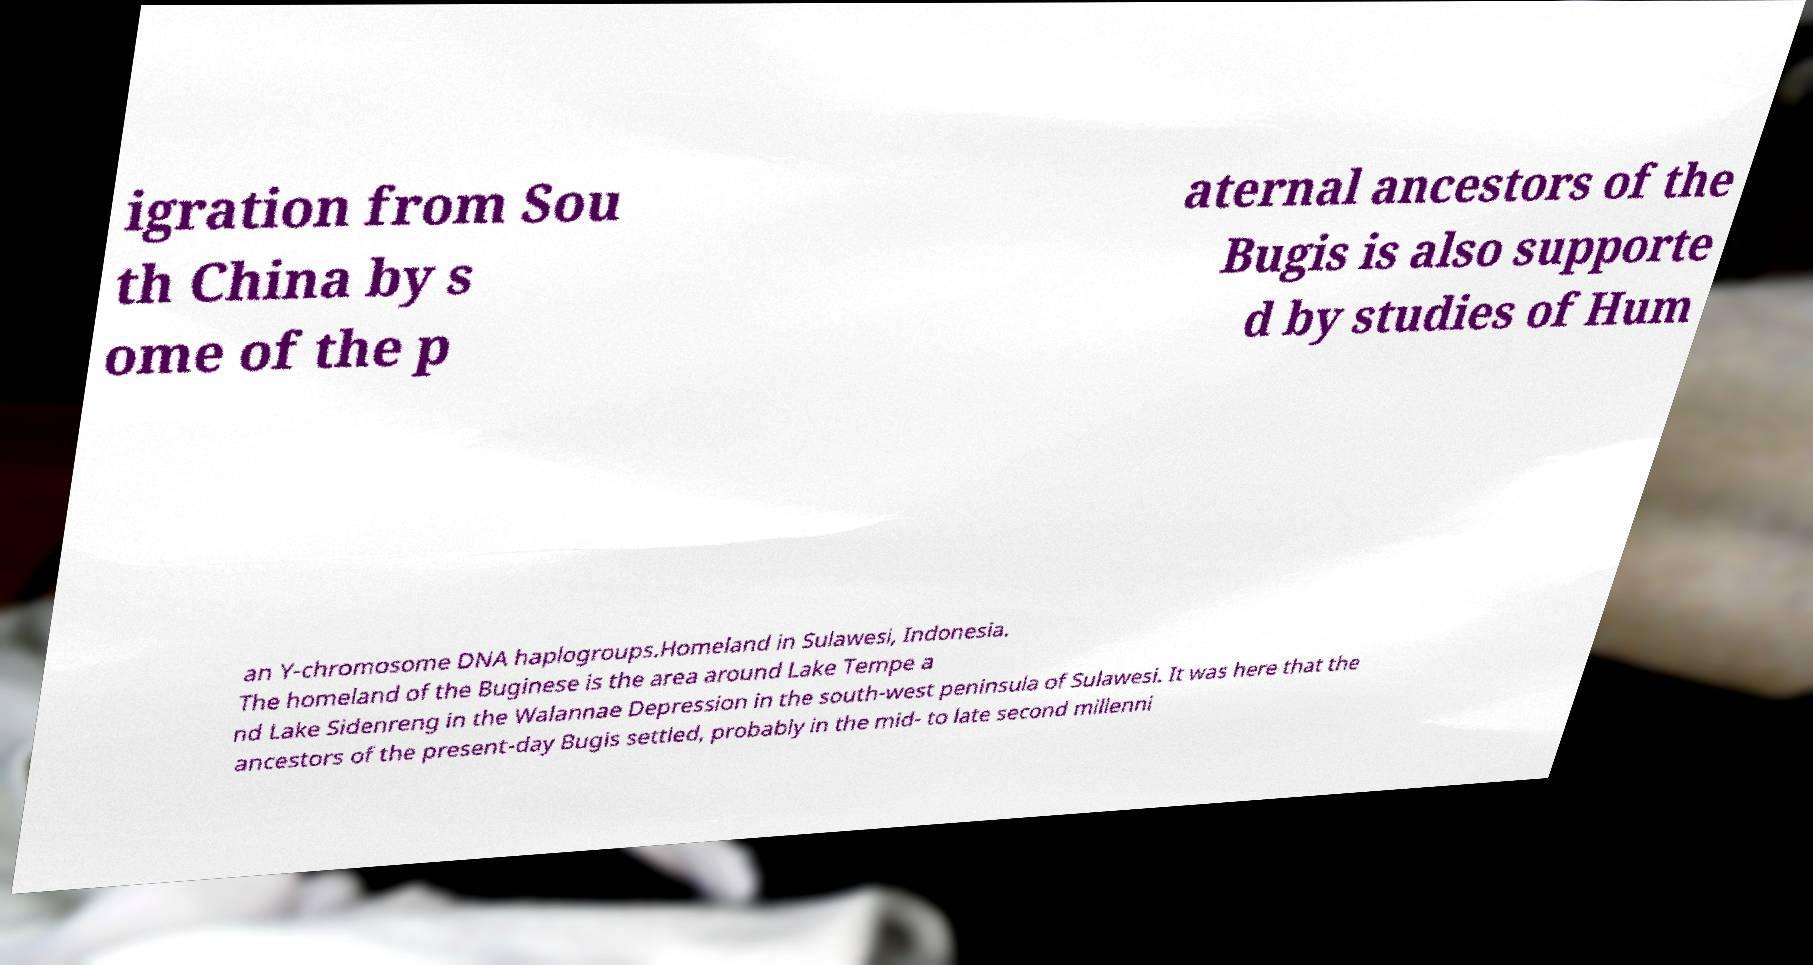I need the written content from this picture converted into text. Can you do that? igration from Sou th China by s ome of the p aternal ancestors of the Bugis is also supporte d by studies of Hum an Y-chromosome DNA haplogroups.Homeland in Sulawesi, Indonesia. The homeland of the Buginese is the area around Lake Tempe a nd Lake Sidenreng in the Walannae Depression in the south-west peninsula of Sulawesi. It was here that the ancestors of the present-day Bugis settled, probably in the mid- to late second millenni 